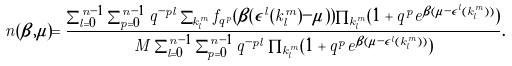Convert formula to latex. <formula><loc_0><loc_0><loc_500><loc_500>n ( \beta , \mu ) = \frac { \sum _ { l = 0 } ^ { n - 1 } \sum _ { p = 0 } ^ { n - 1 } q ^ { - p l } \sum _ { k _ { l } ^ { m } } f _ { q ^ { p } } ( \beta ( \epsilon ^ { l } ( k _ { l } ^ { m } ) - \mu ) ) \prod _ { k _ { l } ^ { m } } ( 1 + q ^ { p } e ^ { \beta ( \mu - \epsilon ^ { l } ( k _ { l } ^ { m } ) ) } ) } { M \sum _ { l = 0 } ^ { n - 1 } \sum _ { p = 0 } ^ { n - 1 } q ^ { - p l } \prod _ { k _ { l } ^ { m } } ( 1 + q ^ { p } e ^ { \beta ( \mu - \epsilon ^ { l } ( k _ { l } ^ { m } ) ) } ) } .</formula> 